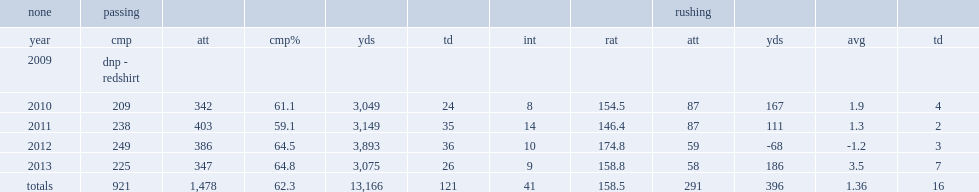How many passing yards did murray have in 2011? 238.0. 